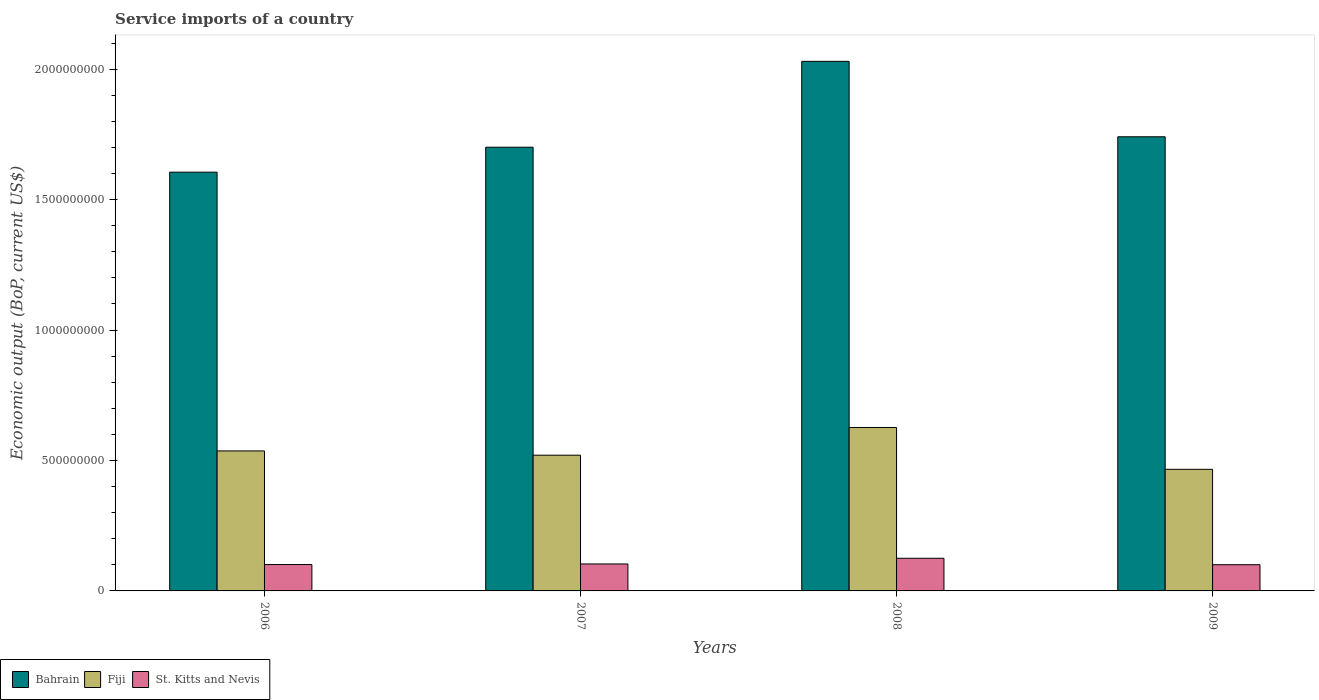How many groups of bars are there?
Your response must be concise. 4. Are the number of bars per tick equal to the number of legend labels?
Ensure brevity in your answer.  Yes. How many bars are there on the 1st tick from the right?
Offer a terse response. 3. What is the label of the 3rd group of bars from the left?
Ensure brevity in your answer.  2008. In how many cases, is the number of bars for a given year not equal to the number of legend labels?
Offer a very short reply. 0. What is the service imports in St. Kitts and Nevis in 2007?
Offer a very short reply. 1.03e+08. Across all years, what is the maximum service imports in Fiji?
Offer a terse response. 6.27e+08. Across all years, what is the minimum service imports in St. Kitts and Nevis?
Ensure brevity in your answer.  1.00e+08. In which year was the service imports in St. Kitts and Nevis minimum?
Your answer should be very brief. 2009. What is the total service imports in Bahrain in the graph?
Offer a terse response. 7.08e+09. What is the difference between the service imports in St. Kitts and Nevis in 2007 and that in 2009?
Offer a terse response. 2.91e+06. What is the difference between the service imports in St. Kitts and Nevis in 2007 and the service imports in Fiji in 2008?
Ensure brevity in your answer.  -5.23e+08. What is the average service imports in St. Kitts and Nevis per year?
Give a very brief answer. 1.08e+08. In the year 2009, what is the difference between the service imports in Fiji and service imports in St. Kitts and Nevis?
Provide a succinct answer. 3.66e+08. In how many years, is the service imports in Bahrain greater than 1600000000 US$?
Keep it short and to the point. 4. What is the ratio of the service imports in Bahrain in 2008 to that in 2009?
Your answer should be compact. 1.17. Is the difference between the service imports in Fiji in 2006 and 2007 greater than the difference between the service imports in St. Kitts and Nevis in 2006 and 2007?
Your response must be concise. Yes. What is the difference between the highest and the second highest service imports in Fiji?
Ensure brevity in your answer.  8.98e+07. What is the difference between the highest and the lowest service imports in Fiji?
Make the answer very short. 1.60e+08. What does the 1st bar from the left in 2008 represents?
Your answer should be very brief. Bahrain. What does the 1st bar from the right in 2006 represents?
Your answer should be compact. St. Kitts and Nevis. How many years are there in the graph?
Offer a terse response. 4. Are the values on the major ticks of Y-axis written in scientific E-notation?
Offer a very short reply. No. How many legend labels are there?
Provide a succinct answer. 3. What is the title of the graph?
Keep it short and to the point. Service imports of a country. What is the label or title of the X-axis?
Provide a short and direct response. Years. What is the label or title of the Y-axis?
Your answer should be very brief. Economic output (BoP, current US$). What is the Economic output (BoP, current US$) in Bahrain in 2006?
Your response must be concise. 1.61e+09. What is the Economic output (BoP, current US$) of Fiji in 2006?
Your answer should be very brief. 5.37e+08. What is the Economic output (BoP, current US$) of St. Kitts and Nevis in 2006?
Make the answer very short. 1.01e+08. What is the Economic output (BoP, current US$) of Bahrain in 2007?
Your answer should be compact. 1.70e+09. What is the Economic output (BoP, current US$) in Fiji in 2007?
Ensure brevity in your answer.  5.20e+08. What is the Economic output (BoP, current US$) in St. Kitts and Nevis in 2007?
Your answer should be compact. 1.03e+08. What is the Economic output (BoP, current US$) of Bahrain in 2008?
Make the answer very short. 2.03e+09. What is the Economic output (BoP, current US$) of Fiji in 2008?
Keep it short and to the point. 6.27e+08. What is the Economic output (BoP, current US$) of St. Kitts and Nevis in 2008?
Keep it short and to the point. 1.25e+08. What is the Economic output (BoP, current US$) of Bahrain in 2009?
Your response must be concise. 1.74e+09. What is the Economic output (BoP, current US$) in Fiji in 2009?
Your response must be concise. 4.66e+08. What is the Economic output (BoP, current US$) in St. Kitts and Nevis in 2009?
Ensure brevity in your answer.  1.00e+08. Across all years, what is the maximum Economic output (BoP, current US$) in Bahrain?
Make the answer very short. 2.03e+09. Across all years, what is the maximum Economic output (BoP, current US$) of Fiji?
Make the answer very short. 6.27e+08. Across all years, what is the maximum Economic output (BoP, current US$) in St. Kitts and Nevis?
Give a very brief answer. 1.25e+08. Across all years, what is the minimum Economic output (BoP, current US$) in Bahrain?
Your response must be concise. 1.61e+09. Across all years, what is the minimum Economic output (BoP, current US$) of Fiji?
Offer a terse response. 4.66e+08. Across all years, what is the minimum Economic output (BoP, current US$) in St. Kitts and Nevis?
Offer a very short reply. 1.00e+08. What is the total Economic output (BoP, current US$) in Bahrain in the graph?
Offer a very short reply. 7.08e+09. What is the total Economic output (BoP, current US$) in Fiji in the graph?
Offer a terse response. 2.15e+09. What is the total Economic output (BoP, current US$) in St. Kitts and Nevis in the graph?
Your response must be concise. 4.30e+08. What is the difference between the Economic output (BoP, current US$) in Bahrain in 2006 and that in 2007?
Your answer should be very brief. -9.57e+07. What is the difference between the Economic output (BoP, current US$) in Fiji in 2006 and that in 2007?
Provide a short and direct response. 1.64e+07. What is the difference between the Economic output (BoP, current US$) in St. Kitts and Nevis in 2006 and that in 2007?
Offer a terse response. -2.25e+06. What is the difference between the Economic output (BoP, current US$) in Bahrain in 2006 and that in 2008?
Your response must be concise. -4.25e+08. What is the difference between the Economic output (BoP, current US$) in Fiji in 2006 and that in 2008?
Your answer should be very brief. -8.98e+07. What is the difference between the Economic output (BoP, current US$) of St. Kitts and Nevis in 2006 and that in 2008?
Keep it short and to the point. -2.40e+07. What is the difference between the Economic output (BoP, current US$) of Bahrain in 2006 and that in 2009?
Your response must be concise. -1.36e+08. What is the difference between the Economic output (BoP, current US$) of Fiji in 2006 and that in 2009?
Keep it short and to the point. 7.06e+07. What is the difference between the Economic output (BoP, current US$) of St. Kitts and Nevis in 2006 and that in 2009?
Your answer should be compact. 6.64e+05. What is the difference between the Economic output (BoP, current US$) of Bahrain in 2007 and that in 2008?
Offer a very short reply. -3.29e+08. What is the difference between the Economic output (BoP, current US$) in Fiji in 2007 and that in 2008?
Provide a succinct answer. -1.06e+08. What is the difference between the Economic output (BoP, current US$) in St. Kitts and Nevis in 2007 and that in 2008?
Offer a very short reply. -2.17e+07. What is the difference between the Economic output (BoP, current US$) of Bahrain in 2007 and that in 2009?
Keep it short and to the point. -4.00e+07. What is the difference between the Economic output (BoP, current US$) of Fiji in 2007 and that in 2009?
Your response must be concise. 5.41e+07. What is the difference between the Economic output (BoP, current US$) of St. Kitts and Nevis in 2007 and that in 2009?
Give a very brief answer. 2.91e+06. What is the difference between the Economic output (BoP, current US$) of Bahrain in 2008 and that in 2009?
Your answer should be compact. 2.89e+08. What is the difference between the Economic output (BoP, current US$) of Fiji in 2008 and that in 2009?
Give a very brief answer. 1.60e+08. What is the difference between the Economic output (BoP, current US$) of St. Kitts and Nevis in 2008 and that in 2009?
Ensure brevity in your answer.  2.46e+07. What is the difference between the Economic output (BoP, current US$) in Bahrain in 2006 and the Economic output (BoP, current US$) in Fiji in 2007?
Your response must be concise. 1.08e+09. What is the difference between the Economic output (BoP, current US$) of Bahrain in 2006 and the Economic output (BoP, current US$) of St. Kitts and Nevis in 2007?
Ensure brevity in your answer.  1.50e+09. What is the difference between the Economic output (BoP, current US$) of Fiji in 2006 and the Economic output (BoP, current US$) of St. Kitts and Nevis in 2007?
Provide a short and direct response. 4.33e+08. What is the difference between the Economic output (BoP, current US$) in Bahrain in 2006 and the Economic output (BoP, current US$) in Fiji in 2008?
Offer a very short reply. 9.79e+08. What is the difference between the Economic output (BoP, current US$) in Bahrain in 2006 and the Economic output (BoP, current US$) in St. Kitts and Nevis in 2008?
Offer a very short reply. 1.48e+09. What is the difference between the Economic output (BoP, current US$) of Fiji in 2006 and the Economic output (BoP, current US$) of St. Kitts and Nevis in 2008?
Your answer should be compact. 4.12e+08. What is the difference between the Economic output (BoP, current US$) in Bahrain in 2006 and the Economic output (BoP, current US$) in Fiji in 2009?
Your answer should be compact. 1.14e+09. What is the difference between the Economic output (BoP, current US$) of Bahrain in 2006 and the Economic output (BoP, current US$) of St. Kitts and Nevis in 2009?
Provide a short and direct response. 1.50e+09. What is the difference between the Economic output (BoP, current US$) of Fiji in 2006 and the Economic output (BoP, current US$) of St. Kitts and Nevis in 2009?
Give a very brief answer. 4.36e+08. What is the difference between the Economic output (BoP, current US$) of Bahrain in 2007 and the Economic output (BoP, current US$) of Fiji in 2008?
Your answer should be very brief. 1.07e+09. What is the difference between the Economic output (BoP, current US$) in Bahrain in 2007 and the Economic output (BoP, current US$) in St. Kitts and Nevis in 2008?
Provide a succinct answer. 1.58e+09. What is the difference between the Economic output (BoP, current US$) in Fiji in 2007 and the Economic output (BoP, current US$) in St. Kitts and Nevis in 2008?
Provide a short and direct response. 3.95e+08. What is the difference between the Economic output (BoP, current US$) of Bahrain in 2007 and the Economic output (BoP, current US$) of Fiji in 2009?
Provide a succinct answer. 1.23e+09. What is the difference between the Economic output (BoP, current US$) of Bahrain in 2007 and the Economic output (BoP, current US$) of St. Kitts and Nevis in 2009?
Offer a very short reply. 1.60e+09. What is the difference between the Economic output (BoP, current US$) of Fiji in 2007 and the Economic output (BoP, current US$) of St. Kitts and Nevis in 2009?
Make the answer very short. 4.20e+08. What is the difference between the Economic output (BoP, current US$) in Bahrain in 2008 and the Economic output (BoP, current US$) in Fiji in 2009?
Your response must be concise. 1.56e+09. What is the difference between the Economic output (BoP, current US$) of Bahrain in 2008 and the Economic output (BoP, current US$) of St. Kitts and Nevis in 2009?
Ensure brevity in your answer.  1.93e+09. What is the difference between the Economic output (BoP, current US$) in Fiji in 2008 and the Economic output (BoP, current US$) in St. Kitts and Nevis in 2009?
Offer a very short reply. 5.26e+08. What is the average Economic output (BoP, current US$) of Bahrain per year?
Your answer should be very brief. 1.77e+09. What is the average Economic output (BoP, current US$) of Fiji per year?
Your answer should be compact. 5.37e+08. What is the average Economic output (BoP, current US$) of St. Kitts and Nevis per year?
Your answer should be compact. 1.08e+08. In the year 2006, what is the difference between the Economic output (BoP, current US$) of Bahrain and Economic output (BoP, current US$) of Fiji?
Offer a very short reply. 1.07e+09. In the year 2006, what is the difference between the Economic output (BoP, current US$) of Bahrain and Economic output (BoP, current US$) of St. Kitts and Nevis?
Make the answer very short. 1.50e+09. In the year 2006, what is the difference between the Economic output (BoP, current US$) in Fiji and Economic output (BoP, current US$) in St. Kitts and Nevis?
Offer a terse response. 4.36e+08. In the year 2007, what is the difference between the Economic output (BoP, current US$) of Bahrain and Economic output (BoP, current US$) of Fiji?
Ensure brevity in your answer.  1.18e+09. In the year 2007, what is the difference between the Economic output (BoP, current US$) of Bahrain and Economic output (BoP, current US$) of St. Kitts and Nevis?
Keep it short and to the point. 1.60e+09. In the year 2007, what is the difference between the Economic output (BoP, current US$) in Fiji and Economic output (BoP, current US$) in St. Kitts and Nevis?
Your answer should be very brief. 4.17e+08. In the year 2008, what is the difference between the Economic output (BoP, current US$) of Bahrain and Economic output (BoP, current US$) of Fiji?
Offer a very short reply. 1.40e+09. In the year 2008, what is the difference between the Economic output (BoP, current US$) of Bahrain and Economic output (BoP, current US$) of St. Kitts and Nevis?
Provide a succinct answer. 1.90e+09. In the year 2008, what is the difference between the Economic output (BoP, current US$) of Fiji and Economic output (BoP, current US$) of St. Kitts and Nevis?
Your response must be concise. 5.01e+08. In the year 2009, what is the difference between the Economic output (BoP, current US$) in Bahrain and Economic output (BoP, current US$) in Fiji?
Offer a very short reply. 1.27e+09. In the year 2009, what is the difference between the Economic output (BoP, current US$) of Bahrain and Economic output (BoP, current US$) of St. Kitts and Nevis?
Give a very brief answer. 1.64e+09. In the year 2009, what is the difference between the Economic output (BoP, current US$) in Fiji and Economic output (BoP, current US$) in St. Kitts and Nevis?
Offer a terse response. 3.66e+08. What is the ratio of the Economic output (BoP, current US$) of Bahrain in 2006 to that in 2007?
Provide a succinct answer. 0.94. What is the ratio of the Economic output (BoP, current US$) of Fiji in 2006 to that in 2007?
Provide a short and direct response. 1.03. What is the ratio of the Economic output (BoP, current US$) in St. Kitts and Nevis in 2006 to that in 2007?
Give a very brief answer. 0.98. What is the ratio of the Economic output (BoP, current US$) of Bahrain in 2006 to that in 2008?
Ensure brevity in your answer.  0.79. What is the ratio of the Economic output (BoP, current US$) of Fiji in 2006 to that in 2008?
Your answer should be compact. 0.86. What is the ratio of the Economic output (BoP, current US$) of St. Kitts and Nevis in 2006 to that in 2008?
Your answer should be very brief. 0.81. What is the ratio of the Economic output (BoP, current US$) in Bahrain in 2006 to that in 2009?
Your response must be concise. 0.92. What is the ratio of the Economic output (BoP, current US$) of Fiji in 2006 to that in 2009?
Provide a short and direct response. 1.15. What is the ratio of the Economic output (BoP, current US$) of St. Kitts and Nevis in 2006 to that in 2009?
Your response must be concise. 1.01. What is the ratio of the Economic output (BoP, current US$) in Bahrain in 2007 to that in 2008?
Provide a short and direct response. 0.84. What is the ratio of the Economic output (BoP, current US$) of Fiji in 2007 to that in 2008?
Keep it short and to the point. 0.83. What is the ratio of the Economic output (BoP, current US$) of St. Kitts and Nevis in 2007 to that in 2008?
Offer a very short reply. 0.83. What is the ratio of the Economic output (BoP, current US$) in Bahrain in 2007 to that in 2009?
Offer a terse response. 0.98. What is the ratio of the Economic output (BoP, current US$) in Fiji in 2007 to that in 2009?
Give a very brief answer. 1.12. What is the ratio of the Economic output (BoP, current US$) in St. Kitts and Nevis in 2007 to that in 2009?
Your answer should be very brief. 1.03. What is the ratio of the Economic output (BoP, current US$) of Bahrain in 2008 to that in 2009?
Make the answer very short. 1.17. What is the ratio of the Economic output (BoP, current US$) in Fiji in 2008 to that in 2009?
Your answer should be compact. 1.34. What is the ratio of the Economic output (BoP, current US$) of St. Kitts and Nevis in 2008 to that in 2009?
Your answer should be compact. 1.25. What is the difference between the highest and the second highest Economic output (BoP, current US$) in Bahrain?
Provide a succinct answer. 2.89e+08. What is the difference between the highest and the second highest Economic output (BoP, current US$) of Fiji?
Provide a short and direct response. 8.98e+07. What is the difference between the highest and the second highest Economic output (BoP, current US$) of St. Kitts and Nevis?
Give a very brief answer. 2.17e+07. What is the difference between the highest and the lowest Economic output (BoP, current US$) of Bahrain?
Make the answer very short. 4.25e+08. What is the difference between the highest and the lowest Economic output (BoP, current US$) of Fiji?
Give a very brief answer. 1.60e+08. What is the difference between the highest and the lowest Economic output (BoP, current US$) of St. Kitts and Nevis?
Provide a short and direct response. 2.46e+07. 